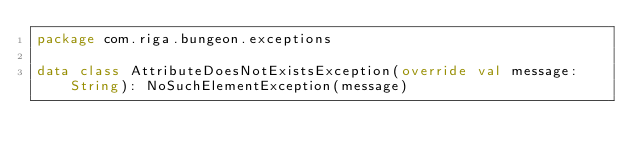<code> <loc_0><loc_0><loc_500><loc_500><_Kotlin_>package com.riga.bungeon.exceptions

data class AttributeDoesNotExistsException(override val message: String): NoSuchElementException(message) </code> 